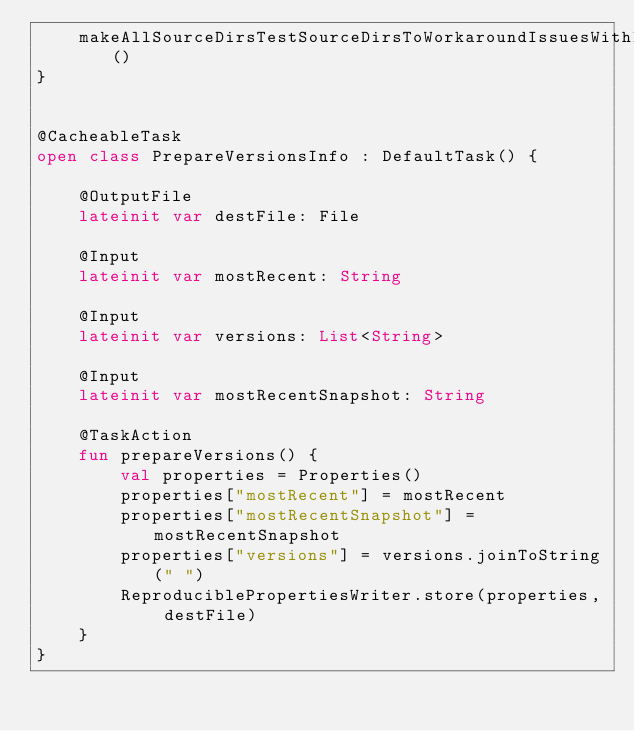<code> <loc_0><loc_0><loc_500><loc_500><_Kotlin_>    makeAllSourceDirsTestSourceDirsToWorkaroundIssuesWithIDEA13()
}


@CacheableTask
open class PrepareVersionsInfo : DefaultTask() {

    @OutputFile
    lateinit var destFile: File

    @Input
    lateinit var mostRecent: String

    @Input
    lateinit var versions: List<String>

    @Input
    lateinit var mostRecentSnapshot: String

    @TaskAction
    fun prepareVersions() {
        val properties = Properties()
        properties["mostRecent"] = mostRecent
        properties["mostRecentSnapshot"] = mostRecentSnapshot
        properties["versions"] = versions.joinToString(" ")
        ReproduciblePropertiesWriter.store(properties, destFile)
    }
}
</code> 